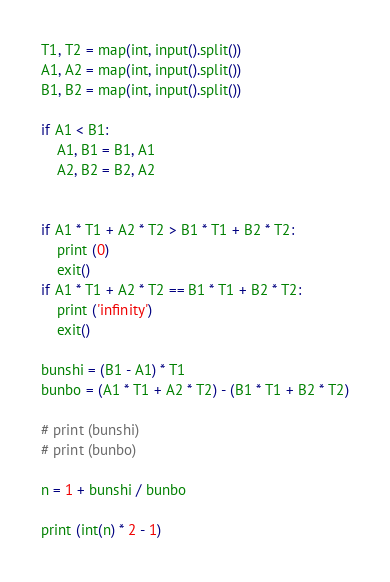Convert code to text. <code><loc_0><loc_0><loc_500><loc_500><_Python_>T1, T2 = map(int, input().split())
A1, A2 = map(int, input().split())
B1, B2 = map(int, input().split())

if A1 < B1:
    A1, B1 = B1, A1
    A2, B2 = B2, A2


if A1 * T1 + A2 * T2 > B1 * T1 + B2 * T2:
    print (0)
    exit()
if A1 * T1 + A2 * T2 == B1 * T1 + B2 * T2:
    print ('infinity')
    exit()

bunshi = (B1 - A1) * T1
bunbo = (A1 * T1 + A2 * T2) - (B1 * T1 + B2 * T2)

# print (bunshi)
# print (bunbo)

n = 1 + bunshi / bunbo

print (int(n) * 2 - 1)</code> 